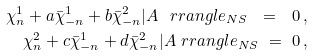<formula> <loc_0><loc_0><loc_500><loc_500>\chi ^ { 1 } _ { n } + a \bar { \chi } ^ { 1 } _ { - n } + b \bar { \chi } ^ { 2 } _ { - n } | A \ r r a n g l e _ { N S } \ = \ 0 \, , \\ \chi ^ { 2 } _ { n } + c \bar { \chi } ^ { 1 } _ { - n } + d \bar { \chi } ^ { 2 } _ { - n } | A \ r r a n g l e _ { N S } \ = \ 0 \, ,</formula> 